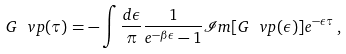Convert formula to latex. <formula><loc_0><loc_0><loc_500><loc_500>G _ { \ } v p ( \tau ) = - \int \frac { d \epsilon } { \pi } \frac { 1 } { e ^ { - \beta \epsilon } - 1 } \mathcal { I } m [ G _ { \ } v p ( \epsilon ) ] e ^ { - \epsilon \tau } \, ,</formula> 